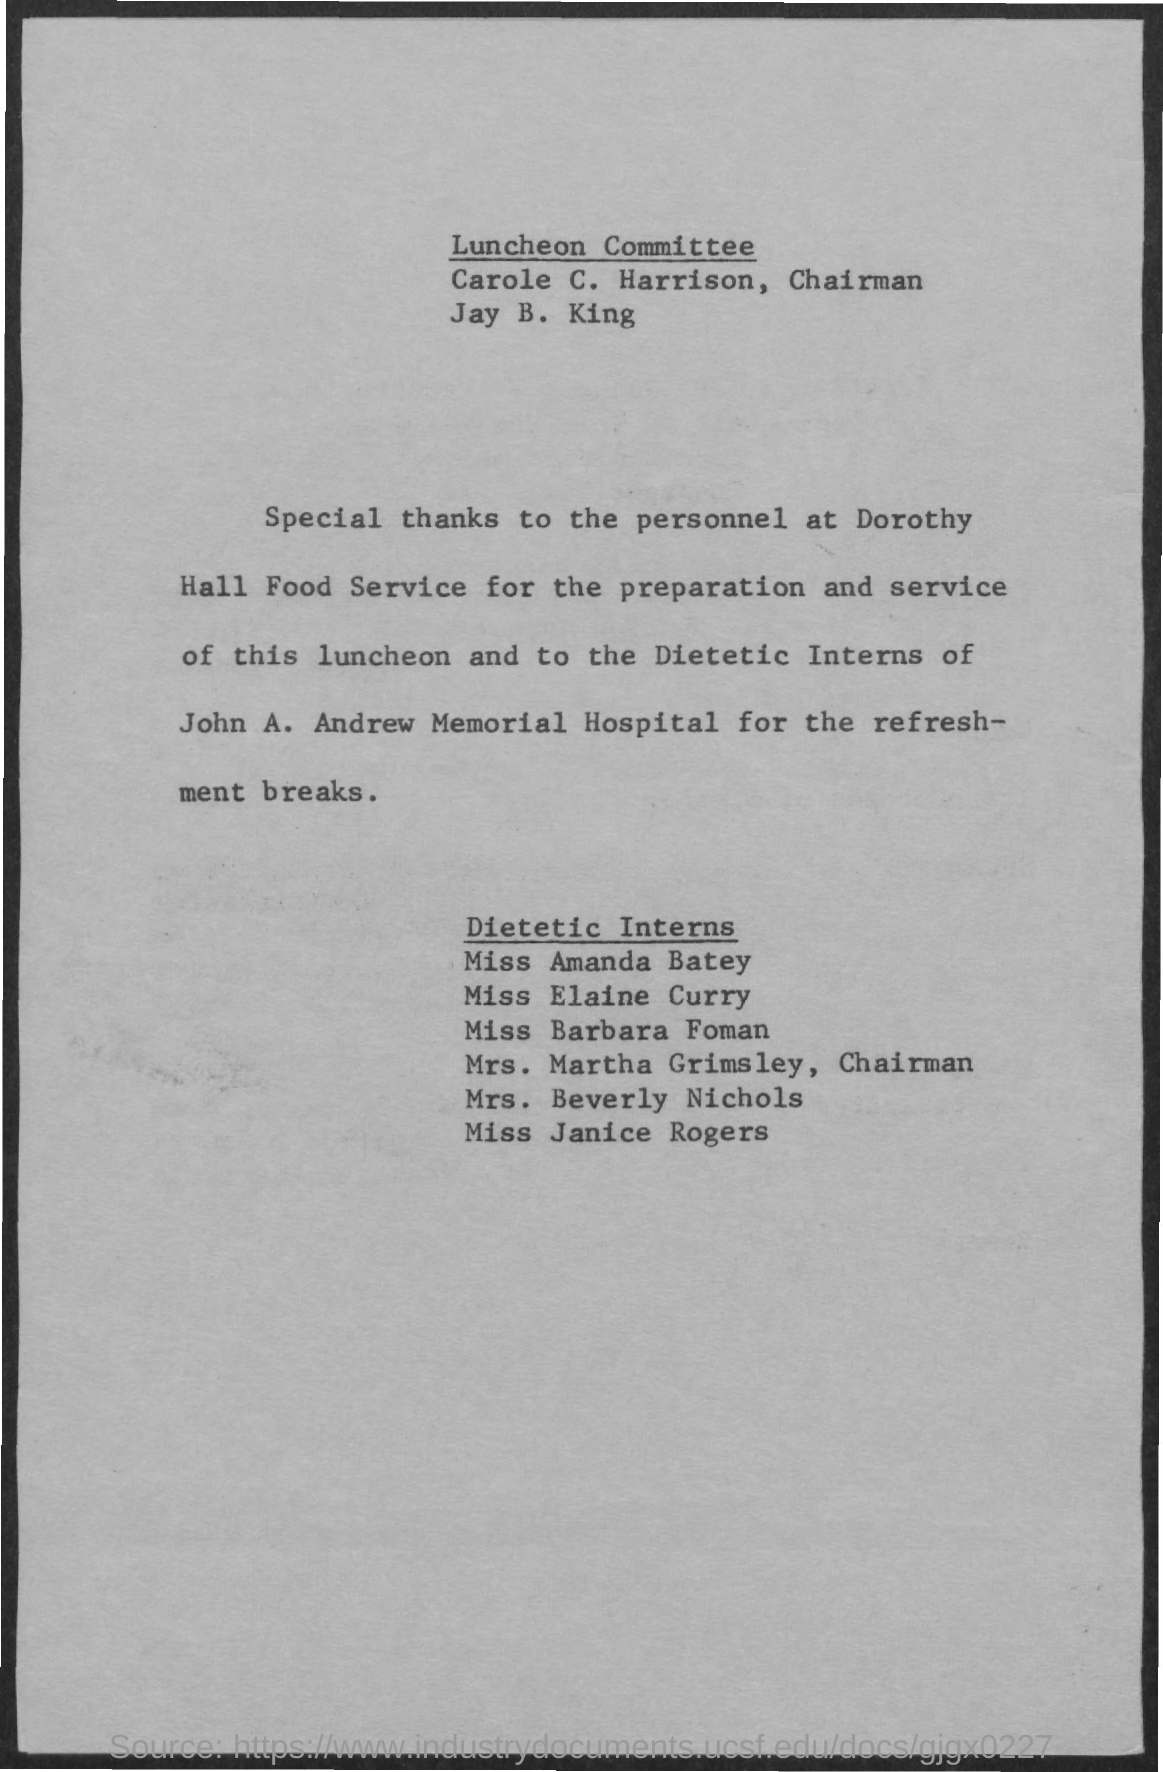Name the hospital mentioned in the document?
Give a very brief answer. John A. Andrew Memorial. 